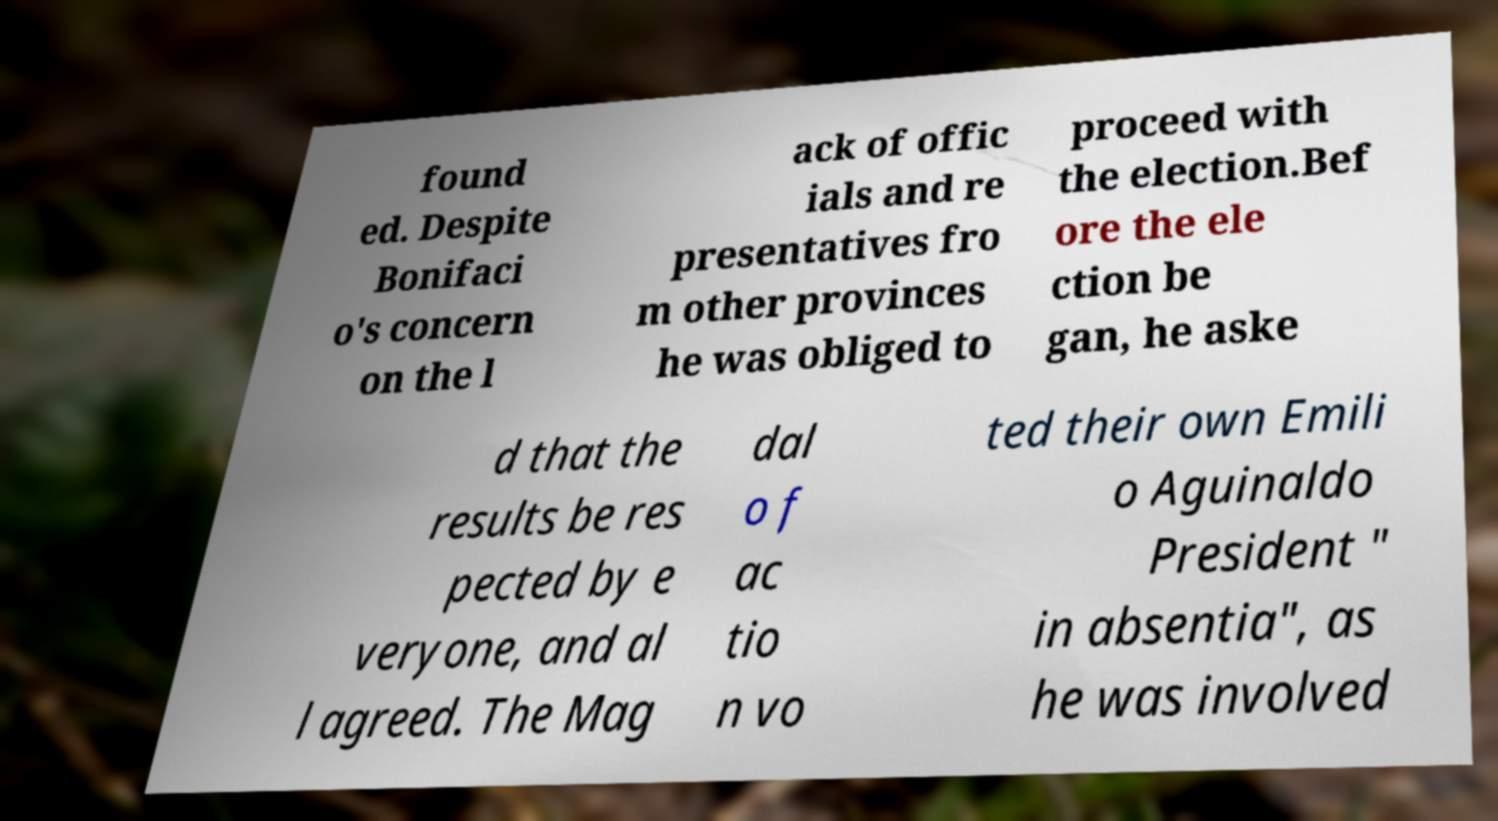Can you accurately transcribe the text from the provided image for me? found ed. Despite Bonifaci o's concern on the l ack of offic ials and re presentatives fro m other provinces he was obliged to proceed with the election.Bef ore the ele ction be gan, he aske d that the results be res pected by e veryone, and al l agreed. The Mag dal o f ac tio n vo ted their own Emili o Aguinaldo President " in absentia", as he was involved 